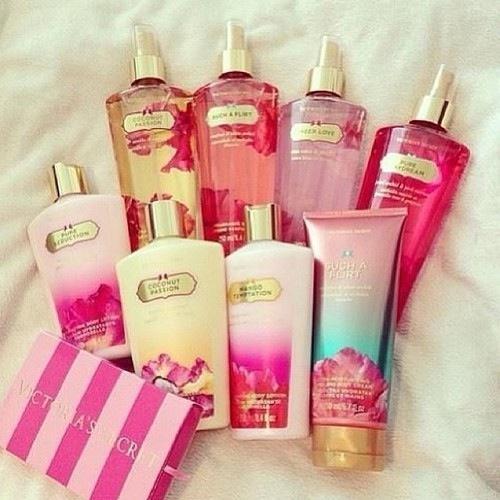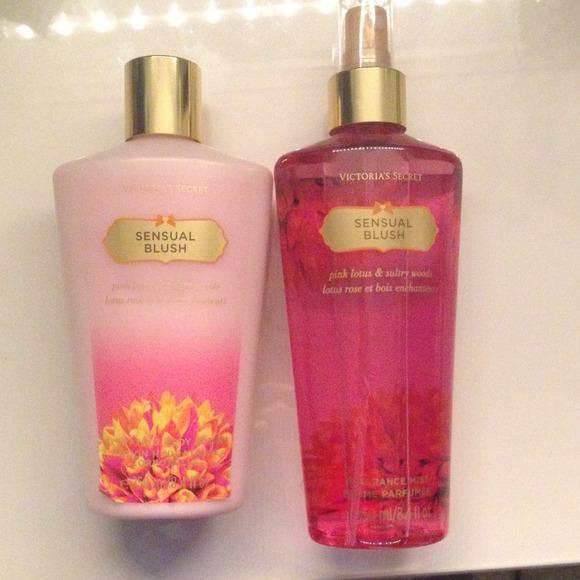The first image is the image on the left, the second image is the image on the right. Given the left and right images, does the statement "More beauty products are pictured in the left image than in the right image." hold true? Answer yes or no. Yes. The first image is the image on the left, the second image is the image on the right. For the images shown, is this caption "The bottles in the left image are arranged on a white cloth background." true? Answer yes or no. Yes. 